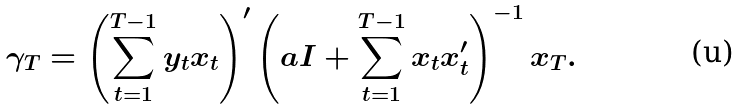Convert formula to latex. <formula><loc_0><loc_0><loc_500><loc_500>\gamma _ { T } = \left ( \sum _ { t = 1 } ^ { T - 1 } y _ { t } x _ { t } \right ) ^ { \prime } \left ( a I + \sum _ { t = 1 } ^ { T - 1 } x _ { t } x _ { t } ^ { \prime } \right ) ^ { - 1 } x _ { T } .</formula> 